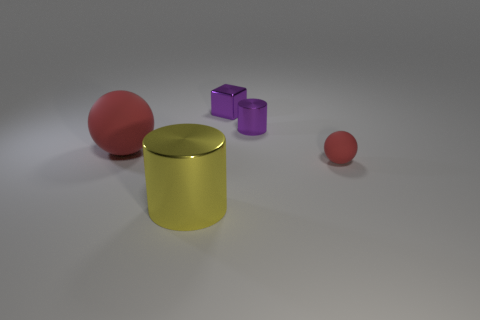Is the number of tiny cubes to the left of the big yellow metal thing less than the number of red rubber balls behind the small purple cylinder?
Your answer should be very brief. No. What size is the purple block that is made of the same material as the big yellow cylinder?
Give a very brief answer. Small. Are there any other things that have the same color as the metallic block?
Your answer should be compact. Yes. Are the tiny block and the cylinder in front of the big red matte ball made of the same material?
Ensure brevity in your answer.  Yes. There is another thing that is the same shape as the yellow metallic object; what material is it?
Provide a succinct answer. Metal. Is the red ball to the right of the large yellow object made of the same material as the red ball on the left side of the small red thing?
Provide a short and direct response. Yes. What color is the metal cylinder in front of the tiny purple object on the right side of the small purple metal object behind the small purple metal cylinder?
Ensure brevity in your answer.  Yellow. How many other things are there of the same shape as the small red thing?
Your answer should be compact. 1. Does the small metallic cylinder have the same color as the small block?
Provide a short and direct response. Yes. How many objects are purple metal blocks or shiny blocks behind the small sphere?
Provide a succinct answer. 1. 